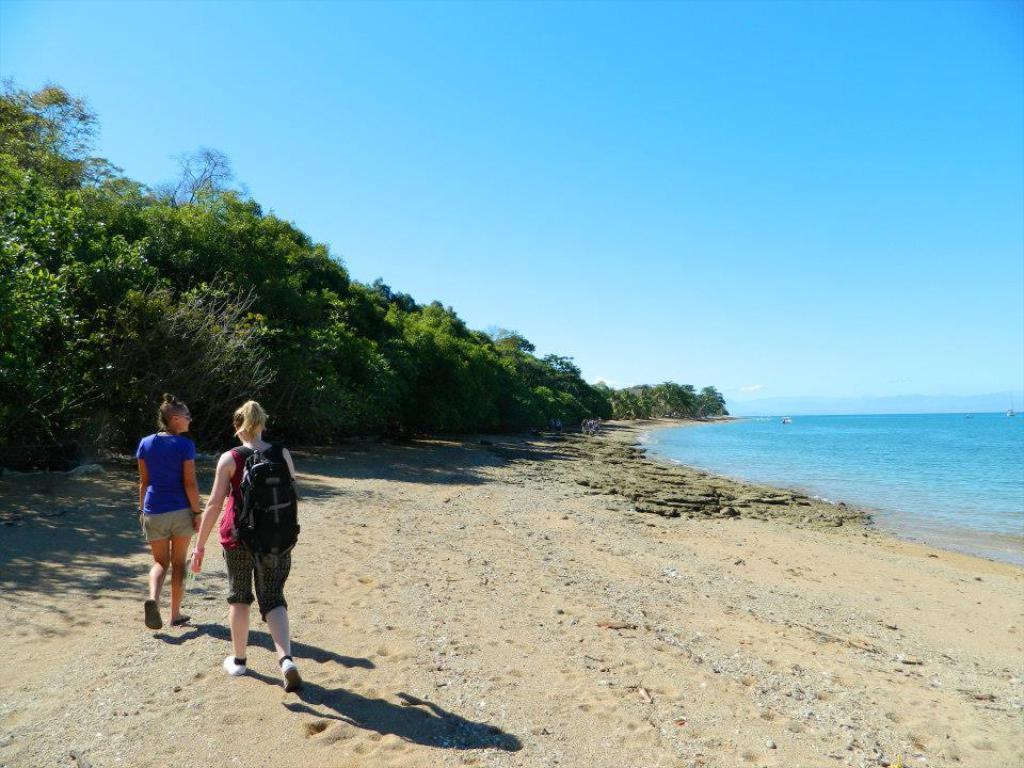Please provide a concise description of this image. In this image we can see this person wearing backpack and shoes and this person wearing blue color T-shirt are walking on the sand. Here we can see the water, trees and the blue color sky in the background. 